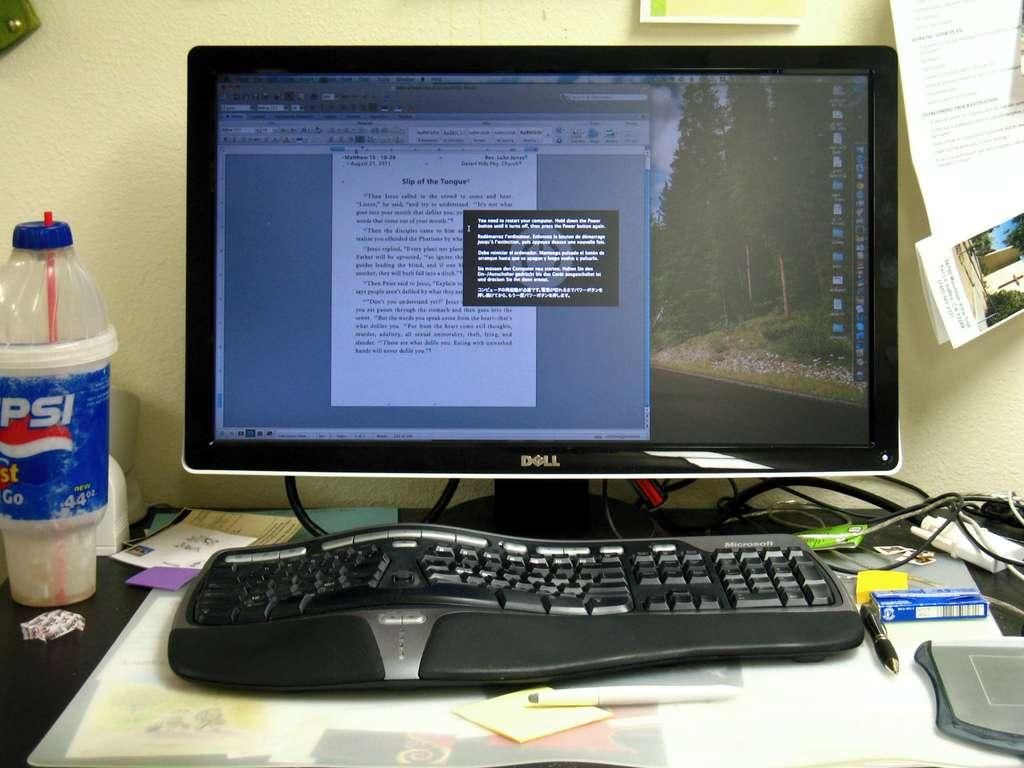<image>
Present a compact description of the photo's key features. A black computer monitor that is from Dell. 